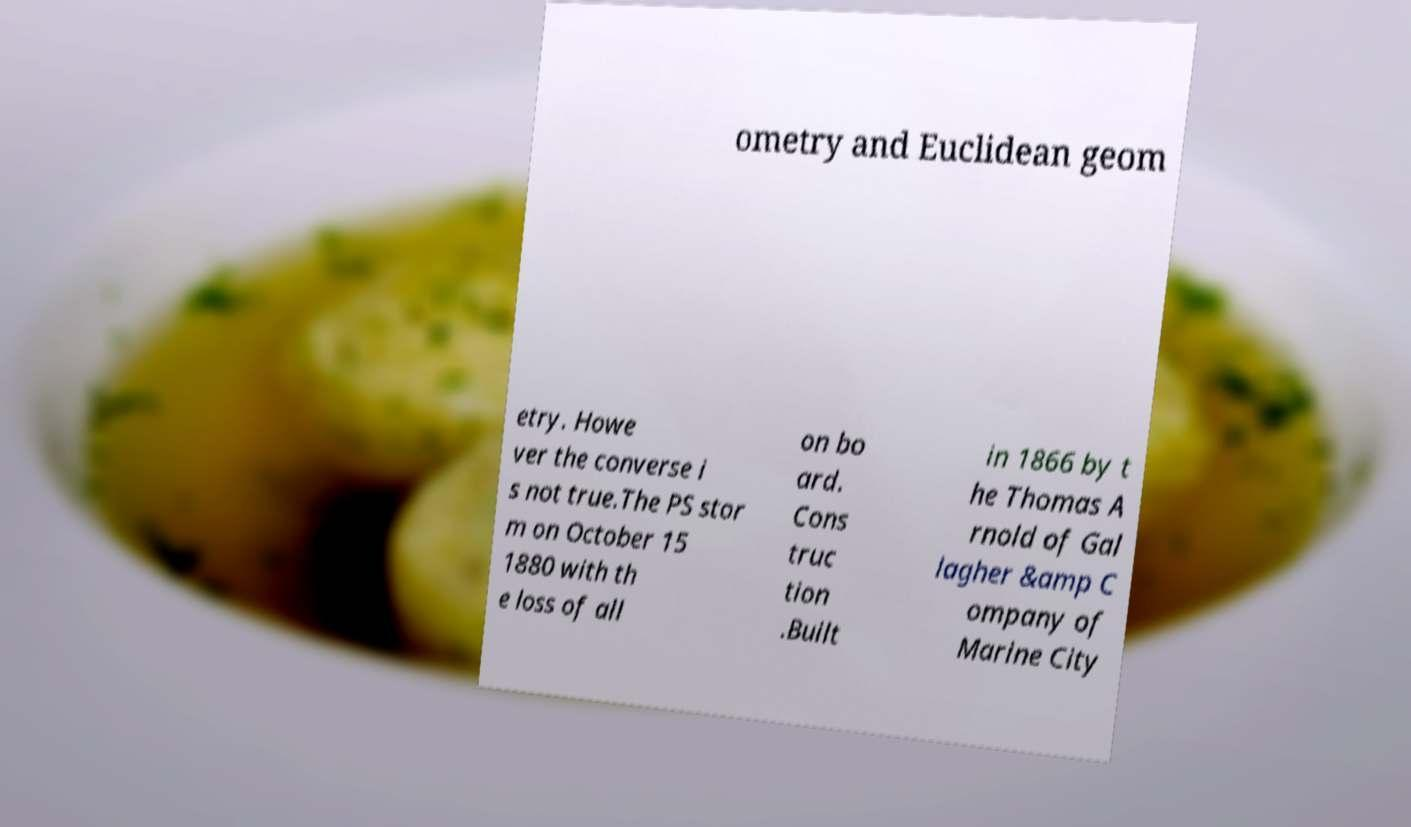Please identify and transcribe the text found in this image. ometry and Euclidean geom etry. Howe ver the converse i s not true.The PS stor m on October 15 1880 with th e loss of all on bo ard. Cons truc tion .Built in 1866 by t he Thomas A rnold of Gal lagher &amp C ompany of Marine City 